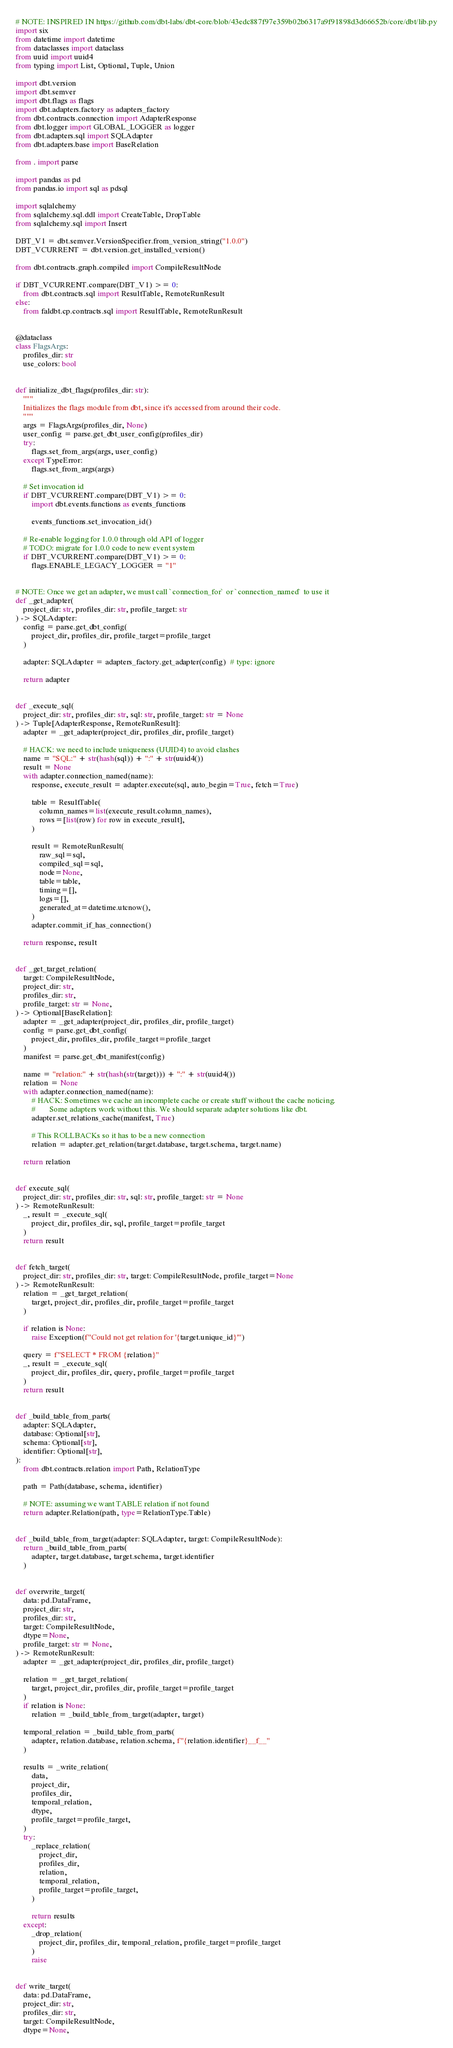Convert code to text. <code><loc_0><loc_0><loc_500><loc_500><_Python_># NOTE: INSPIRED IN https://github.com/dbt-labs/dbt-core/blob/43edc887f97e359b02b6317a9f91898d3d66652b/core/dbt/lib.py
import six
from datetime import datetime
from dataclasses import dataclass
from uuid import uuid4
from typing import List, Optional, Tuple, Union

import dbt.version
import dbt.semver
import dbt.flags as flags
import dbt.adapters.factory as adapters_factory
from dbt.contracts.connection import AdapterResponse
from dbt.logger import GLOBAL_LOGGER as logger
from dbt.adapters.sql import SQLAdapter
from dbt.adapters.base import BaseRelation

from . import parse

import pandas as pd
from pandas.io import sql as pdsql

import sqlalchemy
from sqlalchemy.sql.ddl import CreateTable, DropTable
from sqlalchemy.sql import Insert

DBT_V1 = dbt.semver.VersionSpecifier.from_version_string("1.0.0")
DBT_VCURRENT = dbt.version.get_installed_version()

from dbt.contracts.graph.compiled import CompileResultNode

if DBT_VCURRENT.compare(DBT_V1) >= 0:
    from dbt.contracts.sql import ResultTable, RemoteRunResult
else:
    from faldbt.cp.contracts.sql import ResultTable, RemoteRunResult


@dataclass
class FlagsArgs:
    profiles_dir: str
    use_colors: bool


def initialize_dbt_flags(profiles_dir: str):
    """
    Initializes the flags module from dbt, since it's accessed from around their code.
    """
    args = FlagsArgs(profiles_dir, None)
    user_config = parse.get_dbt_user_config(profiles_dir)
    try:
        flags.set_from_args(args, user_config)
    except TypeError:
        flags.set_from_args(args)

    # Set invocation id
    if DBT_VCURRENT.compare(DBT_V1) >= 0:
        import dbt.events.functions as events_functions

        events_functions.set_invocation_id()

    # Re-enable logging for 1.0.0 through old API of logger
    # TODO: migrate for 1.0.0 code to new event system
    if DBT_VCURRENT.compare(DBT_V1) >= 0:
        flags.ENABLE_LEGACY_LOGGER = "1"


# NOTE: Once we get an adapter, we must call `connection_for` or `connection_named` to use it
def _get_adapter(
    project_dir: str, profiles_dir: str, profile_target: str
) -> SQLAdapter:
    config = parse.get_dbt_config(
        project_dir, profiles_dir, profile_target=profile_target
    )

    adapter: SQLAdapter = adapters_factory.get_adapter(config)  # type: ignore

    return adapter


def _execute_sql(
    project_dir: str, profiles_dir: str, sql: str, profile_target: str = None
) -> Tuple[AdapterResponse, RemoteRunResult]:
    adapter = _get_adapter(project_dir, profiles_dir, profile_target)

    # HACK: we need to include uniqueness (UUID4) to avoid clashes
    name = "SQL:" + str(hash(sql)) + ":" + str(uuid4())
    result = None
    with adapter.connection_named(name):
        response, execute_result = adapter.execute(sql, auto_begin=True, fetch=True)

        table = ResultTable(
            column_names=list(execute_result.column_names),
            rows=[list(row) for row in execute_result],
        )

        result = RemoteRunResult(
            raw_sql=sql,
            compiled_sql=sql,
            node=None,
            table=table,
            timing=[],
            logs=[],
            generated_at=datetime.utcnow(),
        )
        adapter.commit_if_has_connection()

    return response, result


def _get_target_relation(
    target: CompileResultNode,
    project_dir: str,
    profiles_dir: str,
    profile_target: str = None,
) -> Optional[BaseRelation]:
    adapter = _get_adapter(project_dir, profiles_dir, profile_target)
    config = parse.get_dbt_config(
        project_dir, profiles_dir, profile_target=profile_target
    )
    manifest = parse.get_dbt_manifest(config)

    name = "relation:" + str(hash(str(target))) + ":" + str(uuid4())
    relation = None
    with adapter.connection_named(name):
        # HACK: Sometimes we cache an incomplete cache or create stuff without the cache noticing.
        #       Some adapters work without this. We should separate adapter solutions like dbt.
        adapter.set_relations_cache(manifest, True)

        # This ROLLBACKs so it has to be a new connection
        relation = adapter.get_relation(target.database, target.schema, target.name)

    return relation


def execute_sql(
    project_dir: str, profiles_dir: str, sql: str, profile_target: str = None
) -> RemoteRunResult:
    _, result = _execute_sql(
        project_dir, profiles_dir, sql, profile_target=profile_target
    )
    return result


def fetch_target(
    project_dir: str, profiles_dir: str, target: CompileResultNode, profile_target=None
) -> RemoteRunResult:
    relation = _get_target_relation(
        target, project_dir, profiles_dir, profile_target=profile_target
    )

    if relation is None:
        raise Exception(f"Could not get relation for '{target.unique_id}'")

    query = f"SELECT * FROM {relation}"
    _, result = _execute_sql(
        project_dir, profiles_dir, query, profile_target=profile_target
    )
    return result


def _build_table_from_parts(
    adapter: SQLAdapter,
    database: Optional[str],
    schema: Optional[str],
    identifier: Optional[str],
):
    from dbt.contracts.relation import Path, RelationType

    path = Path(database, schema, identifier)

    # NOTE: assuming we want TABLE relation if not found
    return adapter.Relation(path, type=RelationType.Table)


def _build_table_from_target(adapter: SQLAdapter, target: CompileResultNode):
    return _build_table_from_parts(
        adapter, target.database, target.schema, target.identifier
    )


def overwrite_target(
    data: pd.DataFrame,
    project_dir: str,
    profiles_dir: str,
    target: CompileResultNode,
    dtype=None,
    profile_target: str = None,
) -> RemoteRunResult:
    adapter = _get_adapter(project_dir, profiles_dir, profile_target)

    relation = _get_target_relation(
        target, project_dir, profiles_dir, profile_target=profile_target
    )
    if relation is None:
        relation = _build_table_from_target(adapter, target)

    temporal_relation = _build_table_from_parts(
        adapter, relation.database, relation.schema, f"{relation.identifier}__f__"
    )

    results = _write_relation(
        data,
        project_dir,
        profiles_dir,
        temporal_relation,
        dtype,
        profile_target=profile_target,
    )
    try:
        _replace_relation(
            project_dir,
            profiles_dir,
            relation,
            temporal_relation,
            profile_target=profile_target,
        )

        return results
    except:
        _drop_relation(
            project_dir, profiles_dir, temporal_relation, profile_target=profile_target
        )
        raise


def write_target(
    data: pd.DataFrame,
    project_dir: str,
    profiles_dir: str,
    target: CompileResultNode,
    dtype=None,</code> 